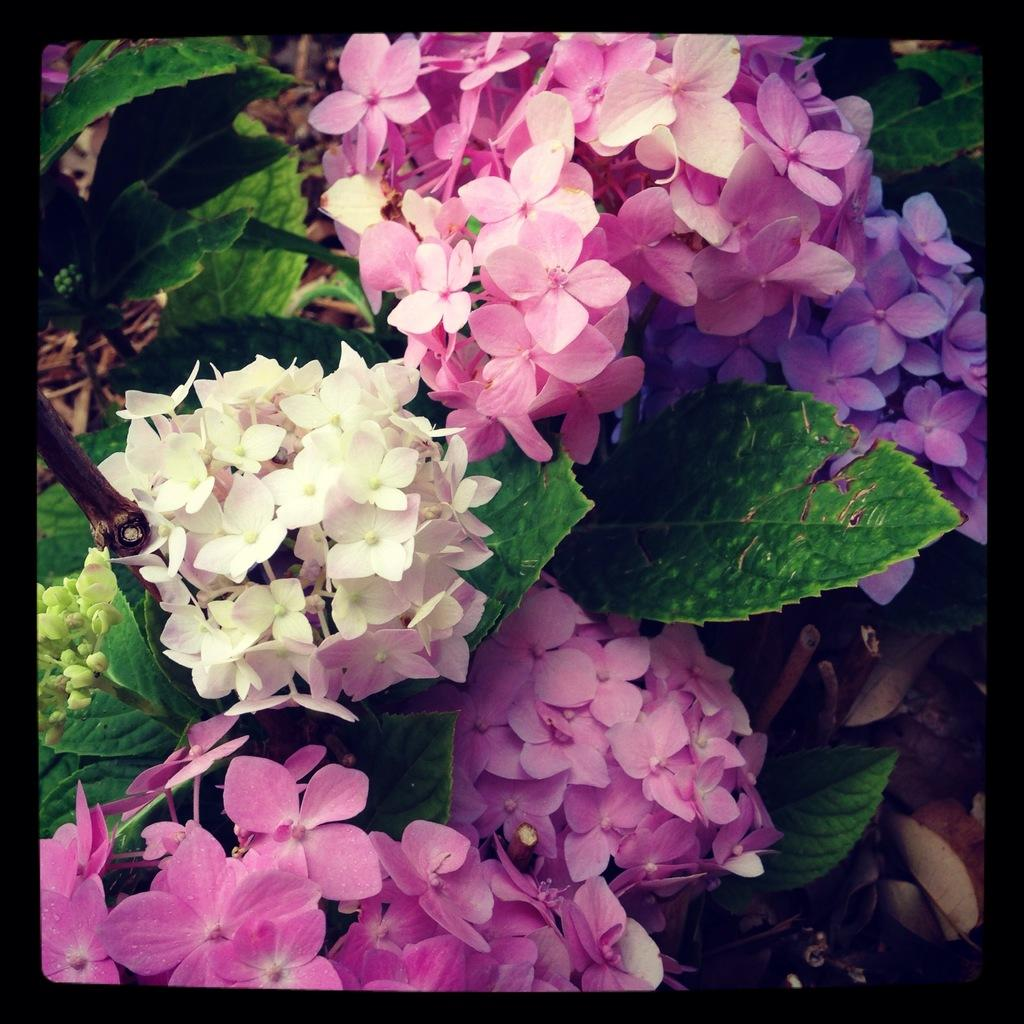What type of plants can be seen in the image? There are colorful flower plants in the image. Can you describe the appearance of the plants? The plants have colorful flowers, which suggests they are vibrant and eye-catching. What might be the purpose of these plants in the image? The plants may be decorative or serve as a natural element in the surrounding environment. How does the salt affect the growth of the flowers in the image? There is no salt present in the image, so its effect on the flowers cannot be determined. 